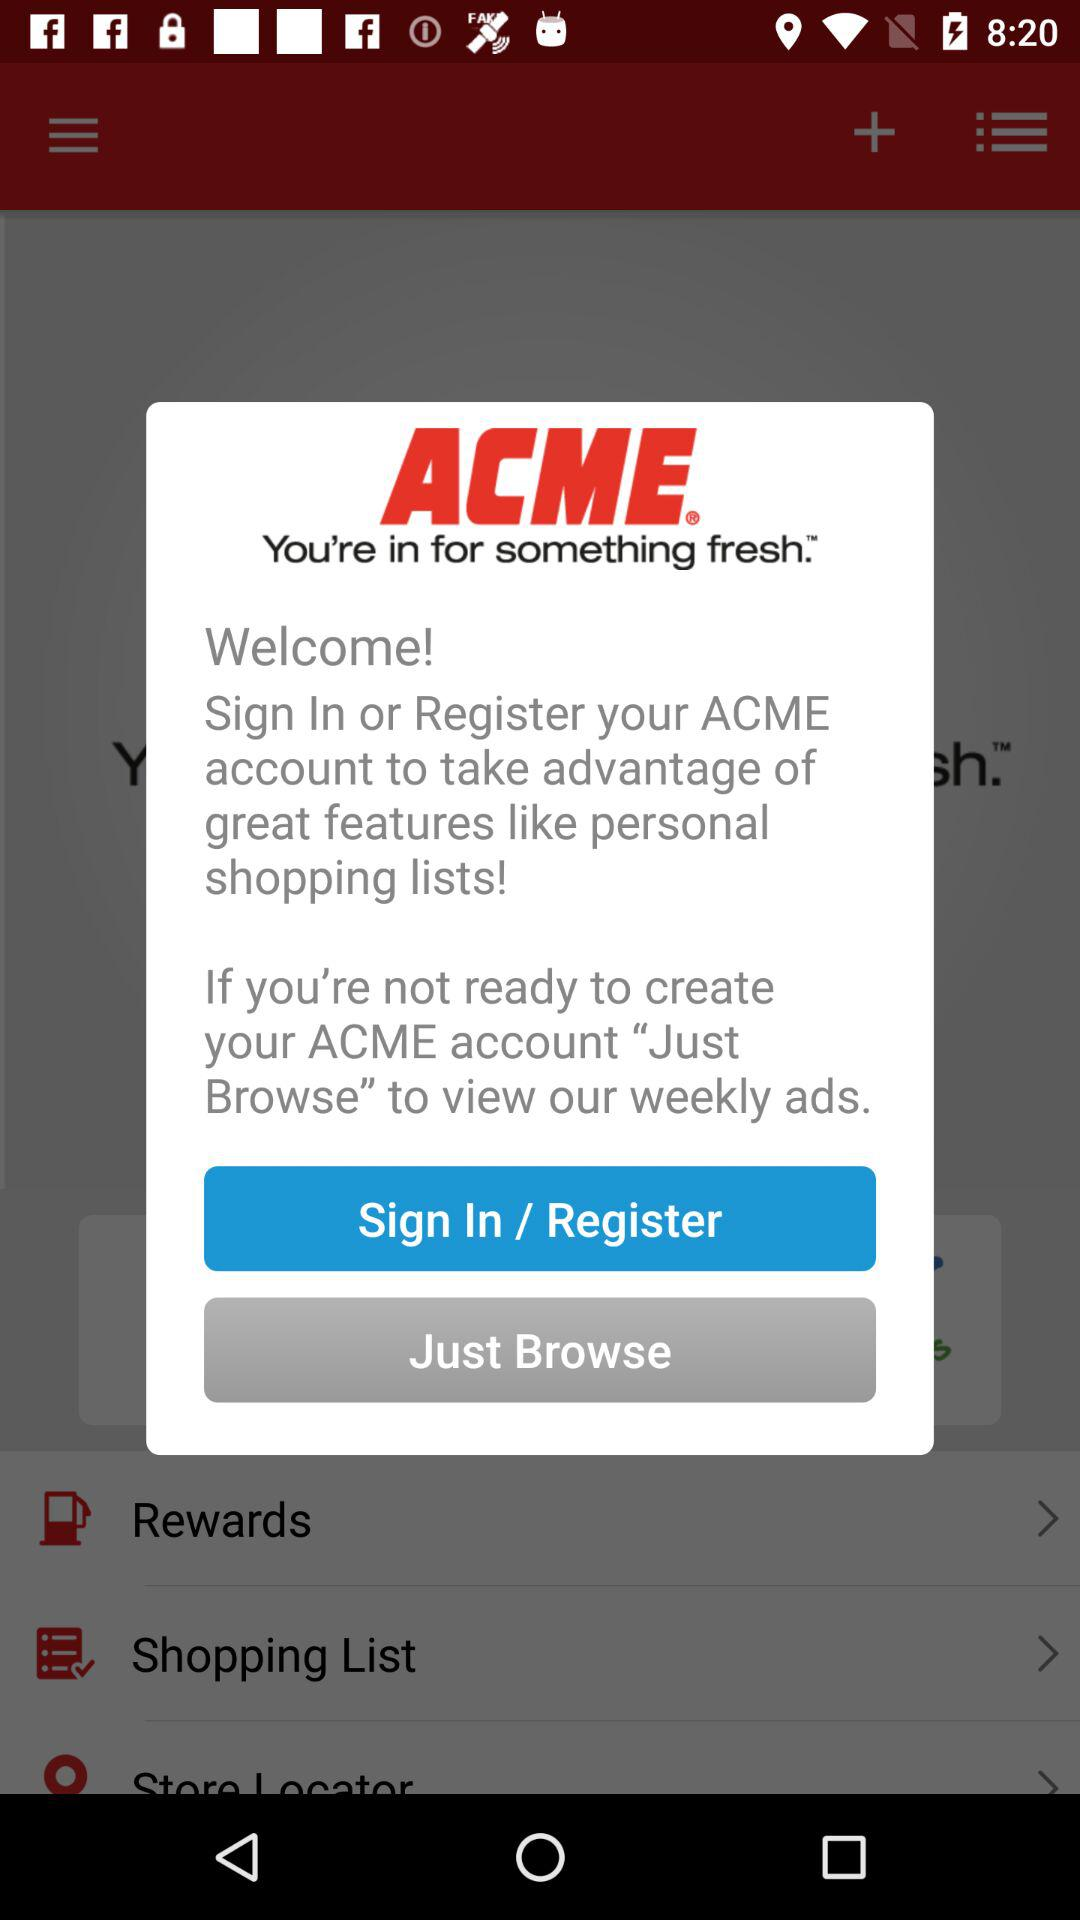What is the name of the application? The name of the application is "ACME". 